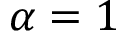<formula> <loc_0><loc_0><loc_500><loc_500>\alpha = 1</formula> 